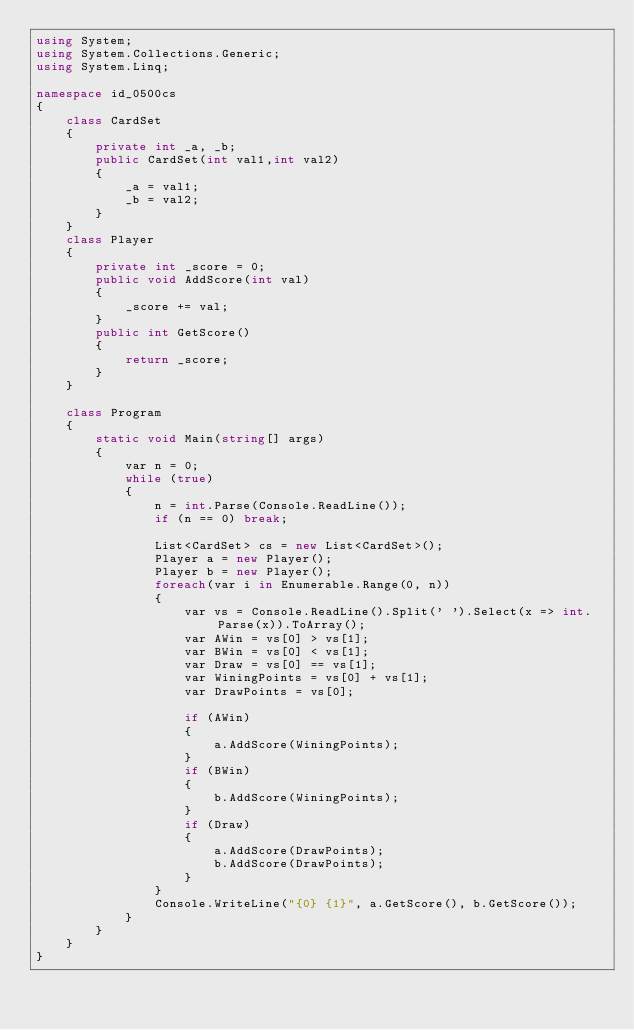<code> <loc_0><loc_0><loc_500><loc_500><_C#_>using System;
using System.Collections.Generic;
using System.Linq;

namespace id_0500cs
{
    class CardSet
    {
        private int _a, _b;
        public CardSet(int val1,int val2)
        {
            _a = val1;
            _b = val2;
        }
    }
    class Player
    {
        private int _score = 0;
        public void AddScore(int val)
        {
            _score += val;
        }
        public int GetScore()
        {
            return _score;
        }
    }

    class Program
    {
        static void Main(string[] args)
        {
            var n = 0;
            while (true)
            {
                n = int.Parse(Console.ReadLine());
                if (n == 0) break;

                List<CardSet> cs = new List<CardSet>();
                Player a = new Player();
                Player b = new Player();
                foreach(var i in Enumerable.Range(0, n))
                {
                    var vs = Console.ReadLine().Split(' ').Select(x => int.Parse(x)).ToArray();
                    var AWin = vs[0] > vs[1];
                    var BWin = vs[0] < vs[1];
                    var Draw = vs[0] == vs[1];
                    var WiningPoints = vs[0] + vs[1];
                    var DrawPoints = vs[0];

                    if (AWin)
                    {
                        a.AddScore(WiningPoints);
                    }
                    if (BWin)
                    {
                        b.AddScore(WiningPoints);
                    }
                    if (Draw)
                    {
                        a.AddScore(DrawPoints);
                        b.AddScore(DrawPoints);
                    }
                }
                Console.WriteLine("{0} {1}", a.GetScore(), b.GetScore());
            }
        }
    }
}

</code> 